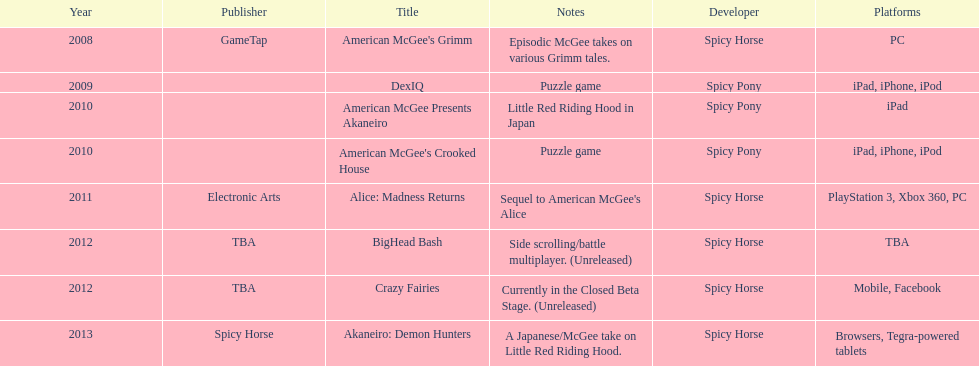What platform was used for the last title on this chart? Browsers, Tegra-powered tablets. 